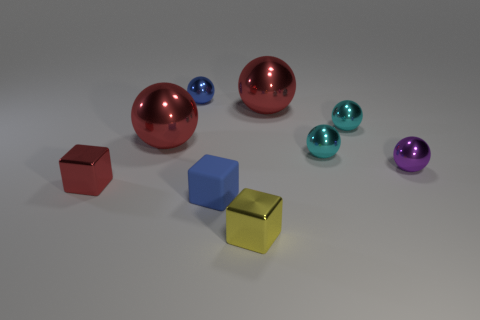How many cyan spheres must be subtracted to get 1 cyan spheres? 1 Subtract all purple spheres. How many spheres are left? 5 Subtract all big red spheres. How many spheres are left? 4 Subtract 1 spheres. How many spheres are left? 5 Subtract all brown spheres. Subtract all cyan blocks. How many spheres are left? 6 Add 1 purple things. How many objects exist? 10 Subtract all cubes. How many objects are left? 6 Subtract 0 gray blocks. How many objects are left? 9 Subtract all small yellow objects. Subtract all metallic spheres. How many objects are left? 2 Add 2 red spheres. How many red spheres are left? 4 